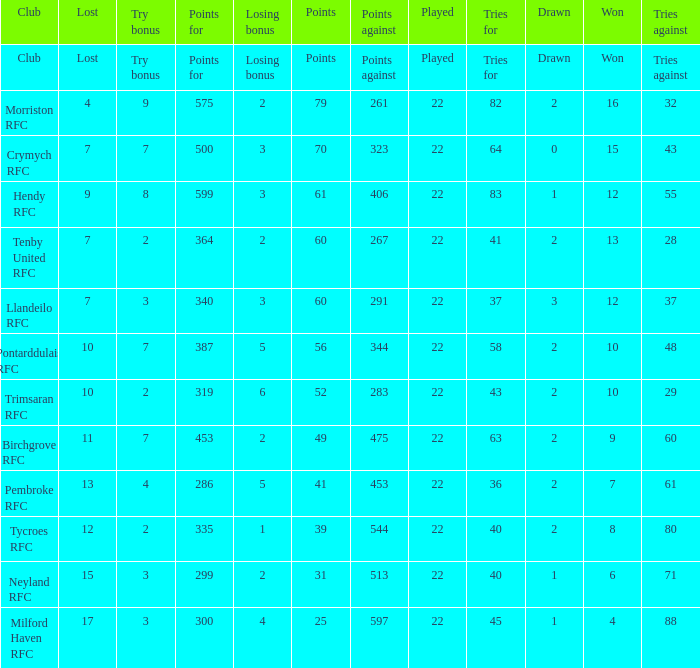What's the points with tries for being 64 70.0. 